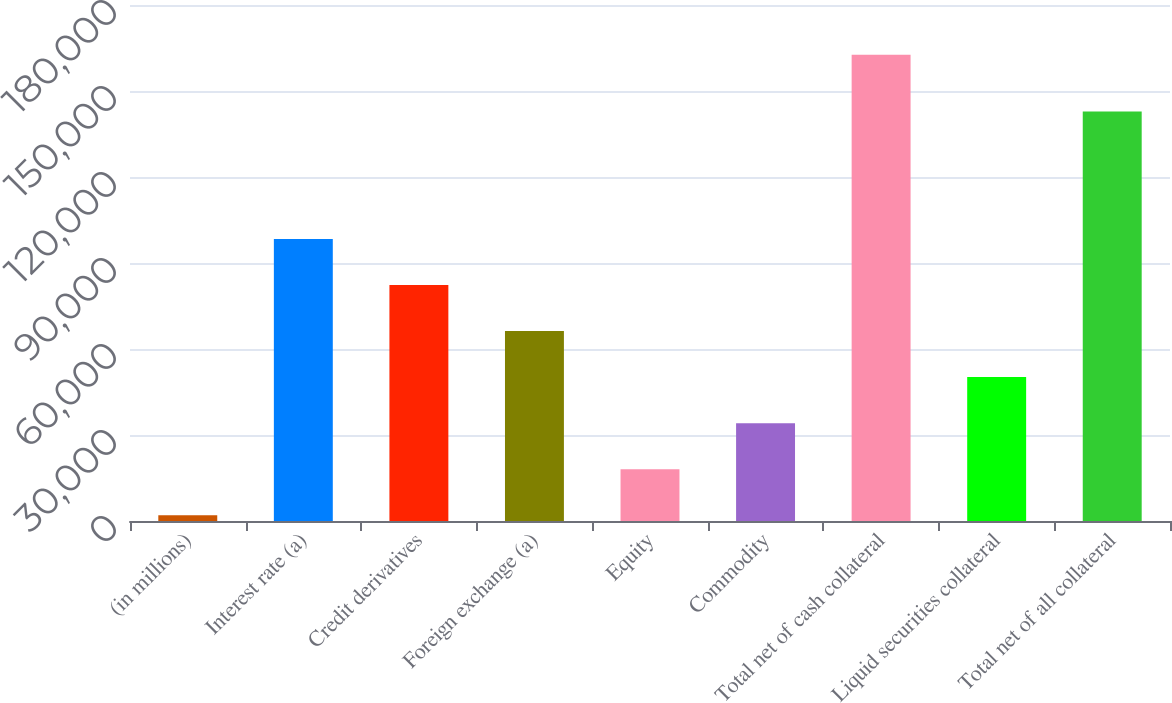<chart> <loc_0><loc_0><loc_500><loc_500><bar_chart><fcel>(in millions)<fcel>Interest rate (a)<fcel>Credit derivatives<fcel>Foreign exchange (a)<fcel>Equity<fcel>Commodity<fcel>Total net of cash collateral<fcel>Liquid securities collateral<fcel>Total net of all collateral<nl><fcel>2008<fcel>98378.8<fcel>82317<fcel>66255.2<fcel>18069.8<fcel>34131.6<fcel>162626<fcel>50193.4<fcel>142810<nl></chart> 